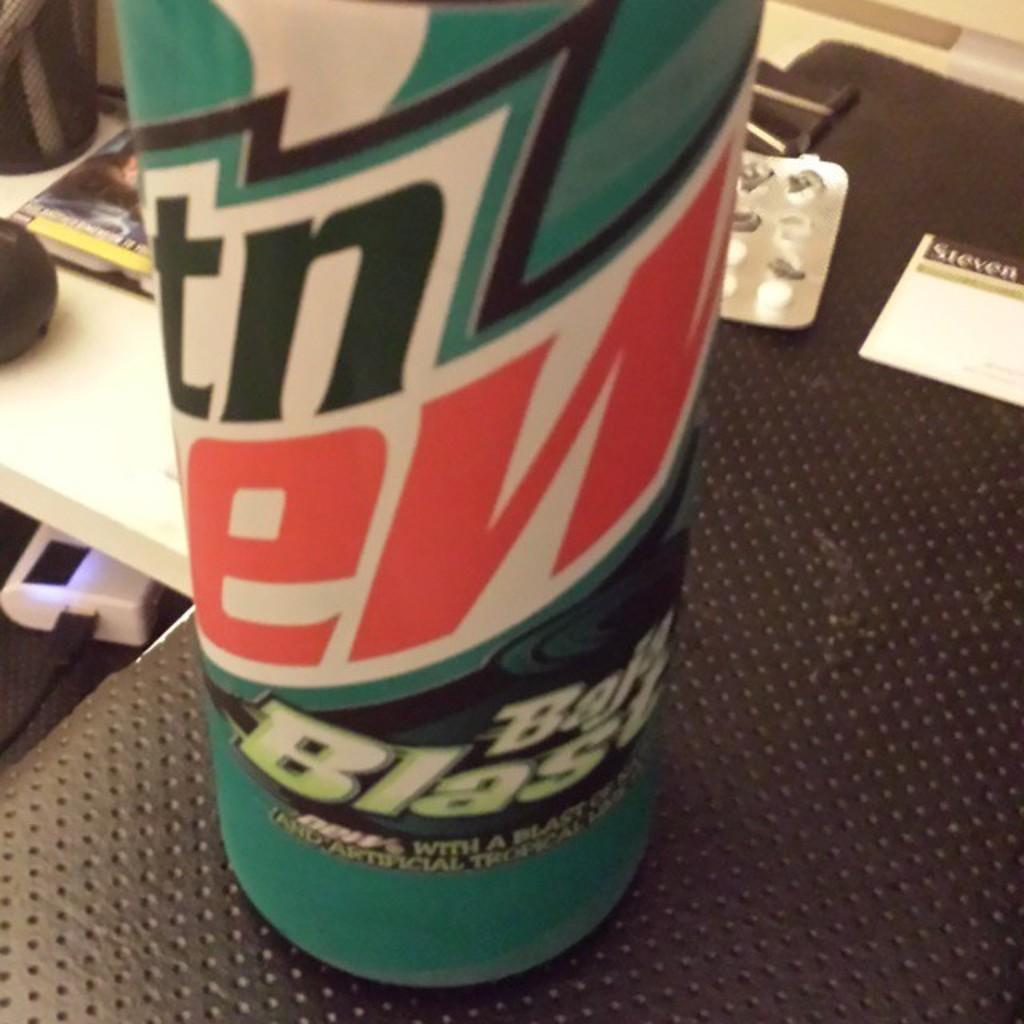<image>
Offer a succinct explanation of the picture presented. a large can of mountain dew baja blast is sitting on a desk 